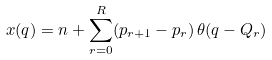<formula> <loc_0><loc_0><loc_500><loc_500>x ( q ) = n + \sum _ { r = 0 } ^ { R } ( p _ { r + 1 } - p _ { r } ) \, \theta ( q - Q _ { r } )</formula> 